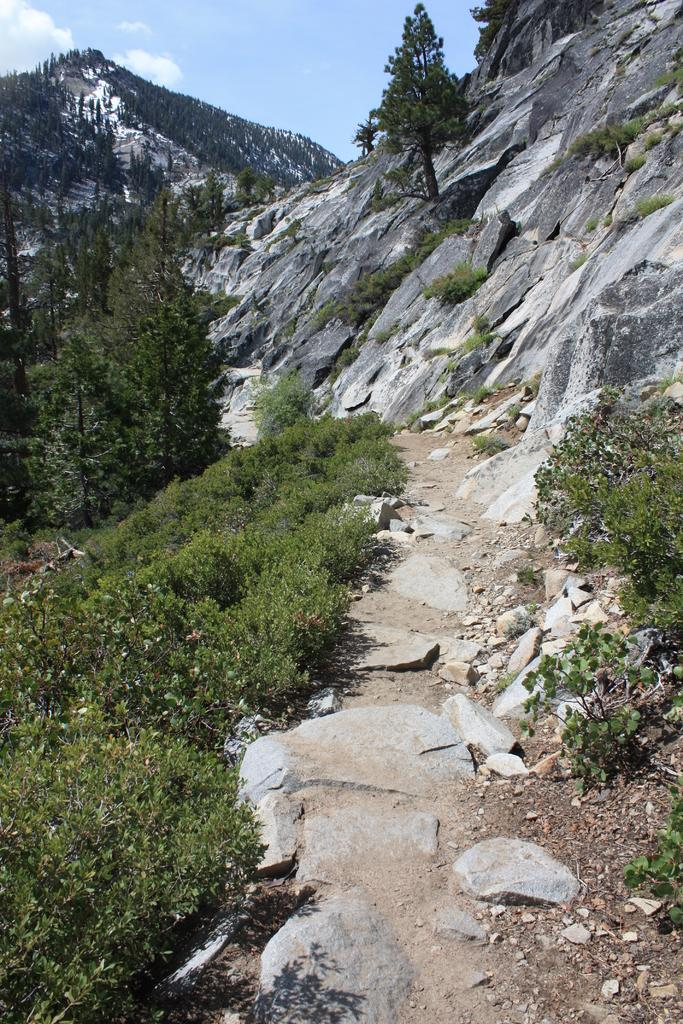What type of vegetation can be seen in the image? There are trees in the image. What geographical features are present in the image? There are hills in the image. What type of ground cover is visible in the image? There is grass in the image. What is visible in the background of the image? The sky is visible in the image. What type of music is being played by the committee in the image? There is no committee or music present in the image. Can you spot a squirrel among the trees in the image? There is no squirrel visible in the image; only trees, hills, grass, and the sky are present. 